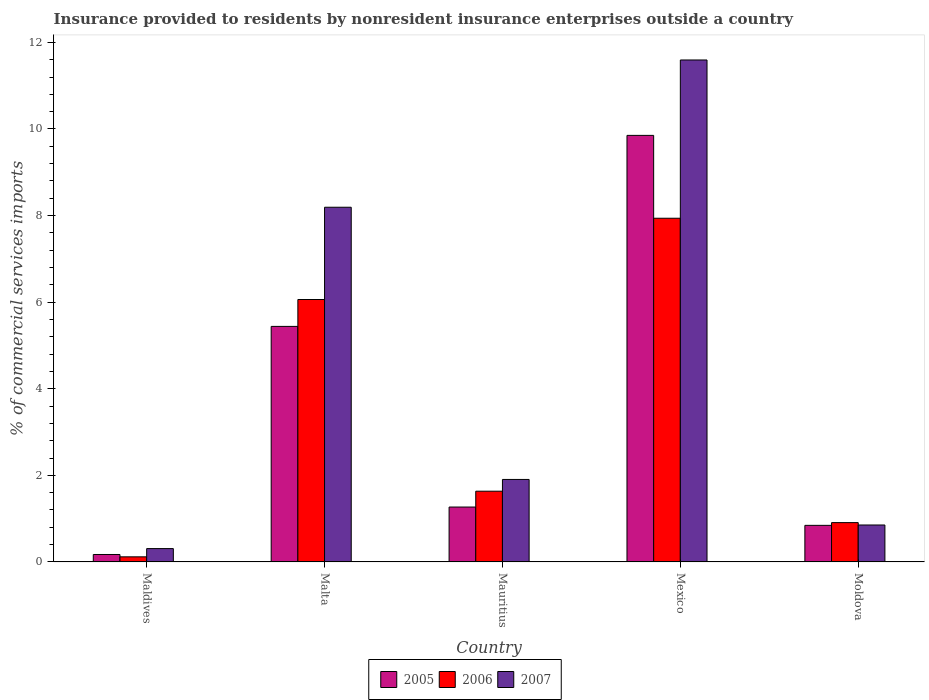How many groups of bars are there?
Offer a very short reply. 5. Are the number of bars per tick equal to the number of legend labels?
Keep it short and to the point. Yes. Are the number of bars on each tick of the X-axis equal?
Make the answer very short. Yes. What is the label of the 3rd group of bars from the left?
Your answer should be compact. Mauritius. In how many cases, is the number of bars for a given country not equal to the number of legend labels?
Make the answer very short. 0. What is the Insurance provided to residents in 2005 in Mauritius?
Provide a succinct answer. 1.27. Across all countries, what is the maximum Insurance provided to residents in 2007?
Offer a terse response. 11.59. Across all countries, what is the minimum Insurance provided to residents in 2006?
Provide a succinct answer. 0.12. In which country was the Insurance provided to residents in 2005 maximum?
Ensure brevity in your answer.  Mexico. In which country was the Insurance provided to residents in 2007 minimum?
Keep it short and to the point. Maldives. What is the total Insurance provided to residents in 2007 in the graph?
Your response must be concise. 22.85. What is the difference between the Insurance provided to residents in 2007 in Maldives and that in Moldova?
Your answer should be very brief. -0.55. What is the difference between the Insurance provided to residents in 2005 in Malta and the Insurance provided to residents in 2007 in Maldives?
Offer a very short reply. 5.13. What is the average Insurance provided to residents in 2007 per country?
Your answer should be compact. 4.57. What is the difference between the Insurance provided to residents of/in 2007 and Insurance provided to residents of/in 2005 in Moldova?
Ensure brevity in your answer.  0.01. In how many countries, is the Insurance provided to residents in 2007 greater than 6 %?
Your answer should be compact. 2. What is the ratio of the Insurance provided to residents in 2006 in Mauritius to that in Mexico?
Keep it short and to the point. 0.21. Is the Insurance provided to residents in 2007 in Malta less than that in Moldova?
Your response must be concise. No. Is the difference between the Insurance provided to residents in 2007 in Maldives and Malta greater than the difference between the Insurance provided to residents in 2005 in Maldives and Malta?
Keep it short and to the point. No. What is the difference between the highest and the second highest Insurance provided to residents in 2007?
Your response must be concise. 6.29. What is the difference between the highest and the lowest Insurance provided to residents in 2007?
Your response must be concise. 11.28. In how many countries, is the Insurance provided to residents in 2007 greater than the average Insurance provided to residents in 2007 taken over all countries?
Offer a terse response. 2. Is the sum of the Insurance provided to residents in 2005 in Maldives and Moldova greater than the maximum Insurance provided to residents in 2006 across all countries?
Your answer should be compact. No. Is it the case that in every country, the sum of the Insurance provided to residents in 2005 and Insurance provided to residents in 2007 is greater than the Insurance provided to residents in 2006?
Make the answer very short. Yes. How many countries are there in the graph?
Your response must be concise. 5. What is the difference between two consecutive major ticks on the Y-axis?
Your response must be concise. 2. Does the graph contain any zero values?
Your response must be concise. No. Does the graph contain grids?
Give a very brief answer. No. Where does the legend appear in the graph?
Make the answer very short. Bottom center. How many legend labels are there?
Offer a very short reply. 3. How are the legend labels stacked?
Ensure brevity in your answer.  Horizontal. What is the title of the graph?
Keep it short and to the point. Insurance provided to residents by nonresident insurance enterprises outside a country. What is the label or title of the Y-axis?
Provide a succinct answer. % of commercial services imports. What is the % of commercial services imports of 2005 in Maldives?
Ensure brevity in your answer.  0.17. What is the % of commercial services imports in 2006 in Maldives?
Ensure brevity in your answer.  0.12. What is the % of commercial services imports in 2007 in Maldives?
Ensure brevity in your answer.  0.31. What is the % of commercial services imports in 2005 in Malta?
Offer a very short reply. 5.44. What is the % of commercial services imports in 2006 in Malta?
Offer a terse response. 6.06. What is the % of commercial services imports in 2007 in Malta?
Provide a succinct answer. 8.19. What is the % of commercial services imports of 2005 in Mauritius?
Make the answer very short. 1.27. What is the % of commercial services imports of 2006 in Mauritius?
Your answer should be very brief. 1.63. What is the % of commercial services imports of 2007 in Mauritius?
Make the answer very short. 1.91. What is the % of commercial services imports in 2005 in Mexico?
Make the answer very short. 9.85. What is the % of commercial services imports in 2006 in Mexico?
Offer a terse response. 7.94. What is the % of commercial services imports of 2007 in Mexico?
Your answer should be very brief. 11.59. What is the % of commercial services imports in 2005 in Moldova?
Provide a succinct answer. 0.85. What is the % of commercial services imports in 2006 in Moldova?
Your answer should be compact. 0.91. What is the % of commercial services imports in 2007 in Moldova?
Provide a succinct answer. 0.85. Across all countries, what is the maximum % of commercial services imports in 2005?
Keep it short and to the point. 9.85. Across all countries, what is the maximum % of commercial services imports in 2006?
Keep it short and to the point. 7.94. Across all countries, what is the maximum % of commercial services imports of 2007?
Make the answer very short. 11.59. Across all countries, what is the minimum % of commercial services imports in 2005?
Offer a very short reply. 0.17. Across all countries, what is the minimum % of commercial services imports in 2006?
Give a very brief answer. 0.12. Across all countries, what is the minimum % of commercial services imports in 2007?
Keep it short and to the point. 0.31. What is the total % of commercial services imports in 2005 in the graph?
Your answer should be compact. 17.58. What is the total % of commercial services imports of 2006 in the graph?
Keep it short and to the point. 16.66. What is the total % of commercial services imports in 2007 in the graph?
Keep it short and to the point. 22.85. What is the difference between the % of commercial services imports in 2005 in Maldives and that in Malta?
Ensure brevity in your answer.  -5.27. What is the difference between the % of commercial services imports of 2006 in Maldives and that in Malta?
Offer a terse response. -5.94. What is the difference between the % of commercial services imports in 2007 in Maldives and that in Malta?
Your answer should be very brief. -7.88. What is the difference between the % of commercial services imports in 2005 in Maldives and that in Mauritius?
Offer a very short reply. -1.1. What is the difference between the % of commercial services imports of 2006 in Maldives and that in Mauritius?
Make the answer very short. -1.52. What is the difference between the % of commercial services imports of 2007 in Maldives and that in Mauritius?
Your response must be concise. -1.6. What is the difference between the % of commercial services imports of 2005 in Maldives and that in Mexico?
Keep it short and to the point. -9.68. What is the difference between the % of commercial services imports in 2006 in Maldives and that in Mexico?
Provide a short and direct response. -7.82. What is the difference between the % of commercial services imports of 2007 in Maldives and that in Mexico?
Your response must be concise. -11.29. What is the difference between the % of commercial services imports of 2005 in Maldives and that in Moldova?
Offer a terse response. -0.67. What is the difference between the % of commercial services imports of 2006 in Maldives and that in Moldova?
Provide a succinct answer. -0.79. What is the difference between the % of commercial services imports of 2007 in Maldives and that in Moldova?
Your response must be concise. -0.55. What is the difference between the % of commercial services imports in 2005 in Malta and that in Mauritius?
Give a very brief answer. 4.17. What is the difference between the % of commercial services imports of 2006 in Malta and that in Mauritius?
Provide a succinct answer. 4.43. What is the difference between the % of commercial services imports of 2007 in Malta and that in Mauritius?
Provide a succinct answer. 6.29. What is the difference between the % of commercial services imports of 2005 in Malta and that in Mexico?
Provide a succinct answer. -4.41. What is the difference between the % of commercial services imports of 2006 in Malta and that in Mexico?
Keep it short and to the point. -1.88. What is the difference between the % of commercial services imports of 2007 in Malta and that in Mexico?
Keep it short and to the point. -3.4. What is the difference between the % of commercial services imports in 2005 in Malta and that in Moldova?
Offer a terse response. 4.59. What is the difference between the % of commercial services imports of 2006 in Malta and that in Moldova?
Keep it short and to the point. 5.15. What is the difference between the % of commercial services imports in 2007 in Malta and that in Moldova?
Offer a terse response. 7.34. What is the difference between the % of commercial services imports of 2005 in Mauritius and that in Mexico?
Ensure brevity in your answer.  -8.58. What is the difference between the % of commercial services imports of 2006 in Mauritius and that in Mexico?
Make the answer very short. -6.3. What is the difference between the % of commercial services imports of 2007 in Mauritius and that in Mexico?
Your answer should be compact. -9.69. What is the difference between the % of commercial services imports of 2005 in Mauritius and that in Moldova?
Offer a very short reply. 0.42. What is the difference between the % of commercial services imports in 2006 in Mauritius and that in Moldova?
Give a very brief answer. 0.73. What is the difference between the % of commercial services imports of 2007 in Mauritius and that in Moldova?
Provide a succinct answer. 1.05. What is the difference between the % of commercial services imports in 2005 in Mexico and that in Moldova?
Give a very brief answer. 9.01. What is the difference between the % of commercial services imports of 2006 in Mexico and that in Moldova?
Provide a succinct answer. 7.03. What is the difference between the % of commercial services imports in 2007 in Mexico and that in Moldova?
Provide a succinct answer. 10.74. What is the difference between the % of commercial services imports of 2005 in Maldives and the % of commercial services imports of 2006 in Malta?
Keep it short and to the point. -5.89. What is the difference between the % of commercial services imports in 2005 in Maldives and the % of commercial services imports in 2007 in Malta?
Keep it short and to the point. -8.02. What is the difference between the % of commercial services imports in 2006 in Maldives and the % of commercial services imports in 2007 in Malta?
Your answer should be very brief. -8.07. What is the difference between the % of commercial services imports of 2005 in Maldives and the % of commercial services imports of 2006 in Mauritius?
Offer a terse response. -1.46. What is the difference between the % of commercial services imports of 2005 in Maldives and the % of commercial services imports of 2007 in Mauritius?
Provide a succinct answer. -1.73. What is the difference between the % of commercial services imports in 2006 in Maldives and the % of commercial services imports in 2007 in Mauritius?
Offer a very short reply. -1.79. What is the difference between the % of commercial services imports in 2005 in Maldives and the % of commercial services imports in 2006 in Mexico?
Keep it short and to the point. -7.77. What is the difference between the % of commercial services imports of 2005 in Maldives and the % of commercial services imports of 2007 in Mexico?
Offer a very short reply. -11.42. What is the difference between the % of commercial services imports in 2006 in Maldives and the % of commercial services imports in 2007 in Mexico?
Offer a very short reply. -11.48. What is the difference between the % of commercial services imports of 2005 in Maldives and the % of commercial services imports of 2006 in Moldova?
Offer a very short reply. -0.74. What is the difference between the % of commercial services imports of 2005 in Maldives and the % of commercial services imports of 2007 in Moldova?
Offer a terse response. -0.68. What is the difference between the % of commercial services imports in 2006 in Maldives and the % of commercial services imports in 2007 in Moldova?
Offer a terse response. -0.74. What is the difference between the % of commercial services imports of 2005 in Malta and the % of commercial services imports of 2006 in Mauritius?
Keep it short and to the point. 3.81. What is the difference between the % of commercial services imports in 2005 in Malta and the % of commercial services imports in 2007 in Mauritius?
Offer a very short reply. 3.53. What is the difference between the % of commercial services imports in 2006 in Malta and the % of commercial services imports in 2007 in Mauritius?
Provide a short and direct response. 4.16. What is the difference between the % of commercial services imports in 2005 in Malta and the % of commercial services imports in 2006 in Mexico?
Provide a succinct answer. -2.5. What is the difference between the % of commercial services imports in 2005 in Malta and the % of commercial services imports in 2007 in Mexico?
Keep it short and to the point. -6.15. What is the difference between the % of commercial services imports of 2006 in Malta and the % of commercial services imports of 2007 in Mexico?
Provide a succinct answer. -5.53. What is the difference between the % of commercial services imports of 2005 in Malta and the % of commercial services imports of 2006 in Moldova?
Your answer should be very brief. 4.53. What is the difference between the % of commercial services imports in 2005 in Malta and the % of commercial services imports in 2007 in Moldova?
Provide a short and direct response. 4.59. What is the difference between the % of commercial services imports of 2006 in Malta and the % of commercial services imports of 2007 in Moldova?
Offer a terse response. 5.21. What is the difference between the % of commercial services imports in 2005 in Mauritius and the % of commercial services imports in 2006 in Mexico?
Provide a short and direct response. -6.67. What is the difference between the % of commercial services imports of 2005 in Mauritius and the % of commercial services imports of 2007 in Mexico?
Provide a short and direct response. -10.33. What is the difference between the % of commercial services imports in 2006 in Mauritius and the % of commercial services imports in 2007 in Mexico?
Your answer should be compact. -9.96. What is the difference between the % of commercial services imports in 2005 in Mauritius and the % of commercial services imports in 2006 in Moldova?
Ensure brevity in your answer.  0.36. What is the difference between the % of commercial services imports of 2005 in Mauritius and the % of commercial services imports of 2007 in Moldova?
Ensure brevity in your answer.  0.41. What is the difference between the % of commercial services imports of 2006 in Mauritius and the % of commercial services imports of 2007 in Moldova?
Offer a terse response. 0.78. What is the difference between the % of commercial services imports of 2005 in Mexico and the % of commercial services imports of 2006 in Moldova?
Make the answer very short. 8.94. What is the difference between the % of commercial services imports in 2005 in Mexico and the % of commercial services imports in 2007 in Moldova?
Provide a short and direct response. 9. What is the difference between the % of commercial services imports in 2006 in Mexico and the % of commercial services imports in 2007 in Moldova?
Your response must be concise. 7.08. What is the average % of commercial services imports of 2005 per country?
Ensure brevity in your answer.  3.52. What is the average % of commercial services imports in 2006 per country?
Make the answer very short. 3.33. What is the average % of commercial services imports in 2007 per country?
Offer a terse response. 4.57. What is the difference between the % of commercial services imports in 2005 and % of commercial services imports in 2006 in Maldives?
Keep it short and to the point. 0.05. What is the difference between the % of commercial services imports in 2005 and % of commercial services imports in 2007 in Maldives?
Your answer should be very brief. -0.14. What is the difference between the % of commercial services imports in 2006 and % of commercial services imports in 2007 in Maldives?
Provide a short and direct response. -0.19. What is the difference between the % of commercial services imports of 2005 and % of commercial services imports of 2006 in Malta?
Give a very brief answer. -0.62. What is the difference between the % of commercial services imports of 2005 and % of commercial services imports of 2007 in Malta?
Provide a short and direct response. -2.75. What is the difference between the % of commercial services imports in 2006 and % of commercial services imports in 2007 in Malta?
Provide a succinct answer. -2.13. What is the difference between the % of commercial services imports in 2005 and % of commercial services imports in 2006 in Mauritius?
Provide a succinct answer. -0.37. What is the difference between the % of commercial services imports of 2005 and % of commercial services imports of 2007 in Mauritius?
Ensure brevity in your answer.  -0.64. What is the difference between the % of commercial services imports of 2006 and % of commercial services imports of 2007 in Mauritius?
Your response must be concise. -0.27. What is the difference between the % of commercial services imports of 2005 and % of commercial services imports of 2006 in Mexico?
Ensure brevity in your answer.  1.91. What is the difference between the % of commercial services imports of 2005 and % of commercial services imports of 2007 in Mexico?
Provide a short and direct response. -1.74. What is the difference between the % of commercial services imports in 2006 and % of commercial services imports in 2007 in Mexico?
Provide a short and direct response. -3.66. What is the difference between the % of commercial services imports in 2005 and % of commercial services imports in 2006 in Moldova?
Provide a short and direct response. -0.06. What is the difference between the % of commercial services imports of 2005 and % of commercial services imports of 2007 in Moldova?
Your answer should be compact. -0.01. What is the difference between the % of commercial services imports in 2006 and % of commercial services imports in 2007 in Moldova?
Keep it short and to the point. 0.05. What is the ratio of the % of commercial services imports of 2005 in Maldives to that in Malta?
Offer a terse response. 0.03. What is the ratio of the % of commercial services imports in 2006 in Maldives to that in Malta?
Offer a terse response. 0.02. What is the ratio of the % of commercial services imports of 2007 in Maldives to that in Malta?
Offer a terse response. 0.04. What is the ratio of the % of commercial services imports in 2005 in Maldives to that in Mauritius?
Ensure brevity in your answer.  0.14. What is the ratio of the % of commercial services imports in 2006 in Maldives to that in Mauritius?
Your answer should be very brief. 0.07. What is the ratio of the % of commercial services imports in 2007 in Maldives to that in Mauritius?
Ensure brevity in your answer.  0.16. What is the ratio of the % of commercial services imports in 2005 in Maldives to that in Mexico?
Offer a very short reply. 0.02. What is the ratio of the % of commercial services imports of 2006 in Maldives to that in Mexico?
Ensure brevity in your answer.  0.01. What is the ratio of the % of commercial services imports of 2007 in Maldives to that in Mexico?
Provide a short and direct response. 0.03. What is the ratio of the % of commercial services imports of 2005 in Maldives to that in Moldova?
Give a very brief answer. 0.2. What is the ratio of the % of commercial services imports in 2006 in Maldives to that in Moldova?
Your answer should be compact. 0.13. What is the ratio of the % of commercial services imports in 2007 in Maldives to that in Moldova?
Keep it short and to the point. 0.36. What is the ratio of the % of commercial services imports in 2005 in Malta to that in Mauritius?
Provide a succinct answer. 4.29. What is the ratio of the % of commercial services imports of 2006 in Malta to that in Mauritius?
Your answer should be very brief. 3.71. What is the ratio of the % of commercial services imports of 2007 in Malta to that in Mauritius?
Make the answer very short. 4.3. What is the ratio of the % of commercial services imports of 2005 in Malta to that in Mexico?
Keep it short and to the point. 0.55. What is the ratio of the % of commercial services imports of 2006 in Malta to that in Mexico?
Your answer should be very brief. 0.76. What is the ratio of the % of commercial services imports in 2007 in Malta to that in Mexico?
Offer a very short reply. 0.71. What is the ratio of the % of commercial services imports of 2005 in Malta to that in Moldova?
Give a very brief answer. 6.44. What is the ratio of the % of commercial services imports of 2006 in Malta to that in Moldova?
Offer a terse response. 6.67. What is the ratio of the % of commercial services imports of 2007 in Malta to that in Moldova?
Your answer should be very brief. 9.6. What is the ratio of the % of commercial services imports of 2005 in Mauritius to that in Mexico?
Ensure brevity in your answer.  0.13. What is the ratio of the % of commercial services imports in 2006 in Mauritius to that in Mexico?
Provide a succinct answer. 0.21. What is the ratio of the % of commercial services imports of 2007 in Mauritius to that in Mexico?
Make the answer very short. 0.16. What is the ratio of the % of commercial services imports of 2005 in Mauritius to that in Moldova?
Give a very brief answer. 1.5. What is the ratio of the % of commercial services imports of 2006 in Mauritius to that in Moldova?
Provide a succinct answer. 1.8. What is the ratio of the % of commercial services imports of 2007 in Mauritius to that in Moldova?
Make the answer very short. 2.23. What is the ratio of the % of commercial services imports in 2005 in Mexico to that in Moldova?
Offer a very short reply. 11.66. What is the ratio of the % of commercial services imports in 2006 in Mexico to that in Moldova?
Ensure brevity in your answer.  8.74. What is the ratio of the % of commercial services imports of 2007 in Mexico to that in Moldova?
Your response must be concise. 13.58. What is the difference between the highest and the second highest % of commercial services imports of 2005?
Offer a very short reply. 4.41. What is the difference between the highest and the second highest % of commercial services imports of 2006?
Give a very brief answer. 1.88. What is the difference between the highest and the second highest % of commercial services imports in 2007?
Your answer should be very brief. 3.4. What is the difference between the highest and the lowest % of commercial services imports of 2005?
Provide a succinct answer. 9.68. What is the difference between the highest and the lowest % of commercial services imports of 2006?
Ensure brevity in your answer.  7.82. What is the difference between the highest and the lowest % of commercial services imports of 2007?
Your response must be concise. 11.29. 